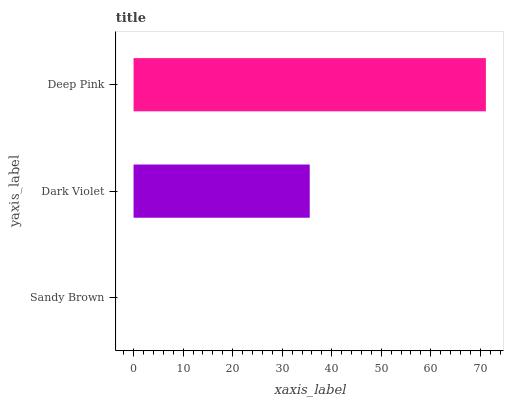Is Sandy Brown the minimum?
Answer yes or no. Yes. Is Deep Pink the maximum?
Answer yes or no. Yes. Is Dark Violet the minimum?
Answer yes or no. No. Is Dark Violet the maximum?
Answer yes or no. No. Is Dark Violet greater than Sandy Brown?
Answer yes or no. Yes. Is Sandy Brown less than Dark Violet?
Answer yes or no. Yes. Is Sandy Brown greater than Dark Violet?
Answer yes or no. No. Is Dark Violet less than Sandy Brown?
Answer yes or no. No. Is Dark Violet the high median?
Answer yes or no. Yes. Is Dark Violet the low median?
Answer yes or no. Yes. Is Deep Pink the high median?
Answer yes or no. No. Is Sandy Brown the low median?
Answer yes or no. No. 